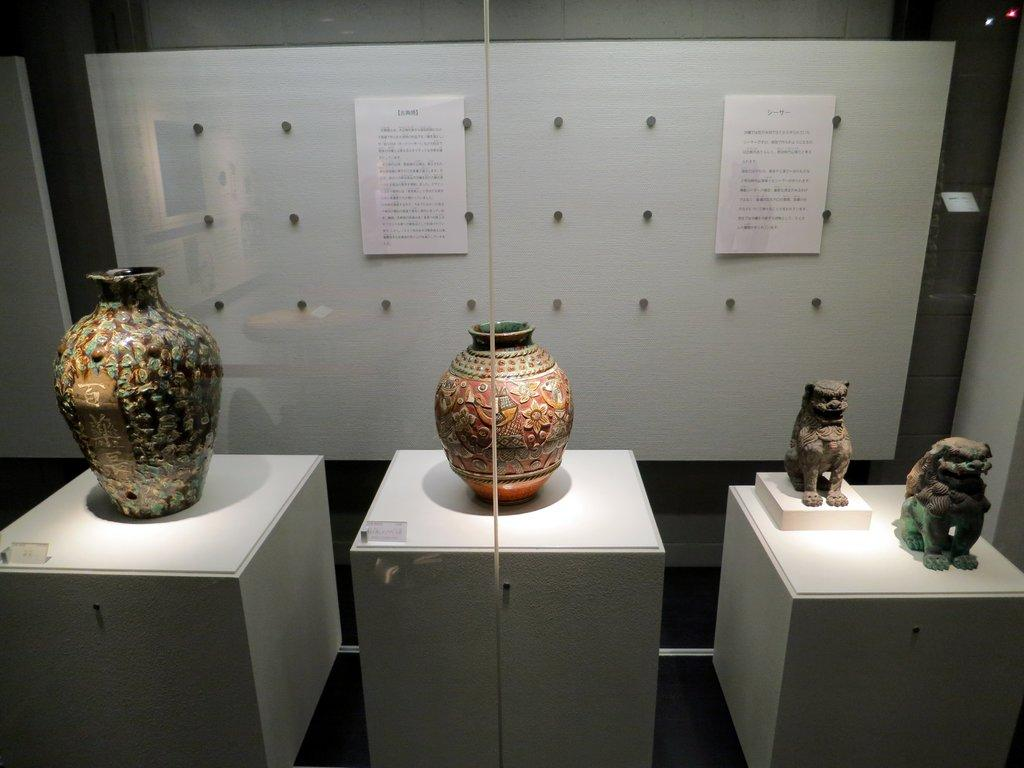How many flower pots are visible in the image? There are two flower pots in the image. What can be found on the table in the image? There are sculptures on the table. What is present in the background of the image? There is wallpaper, boards, and lights in the background of the image. Can you describe the setting where the image might have been taken? The image may have been taken in a hall. What type of ring is being worn by the beast in the image? There is no beast or ring present in the image. How is the rice being used in the image? There is no rice present in the image. 